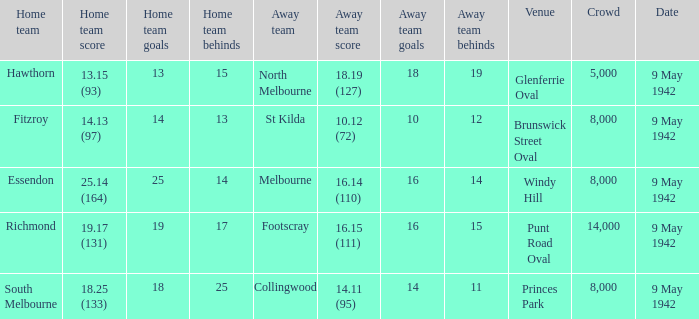How many spectators were at the event where footscray played away? 14000.0. 